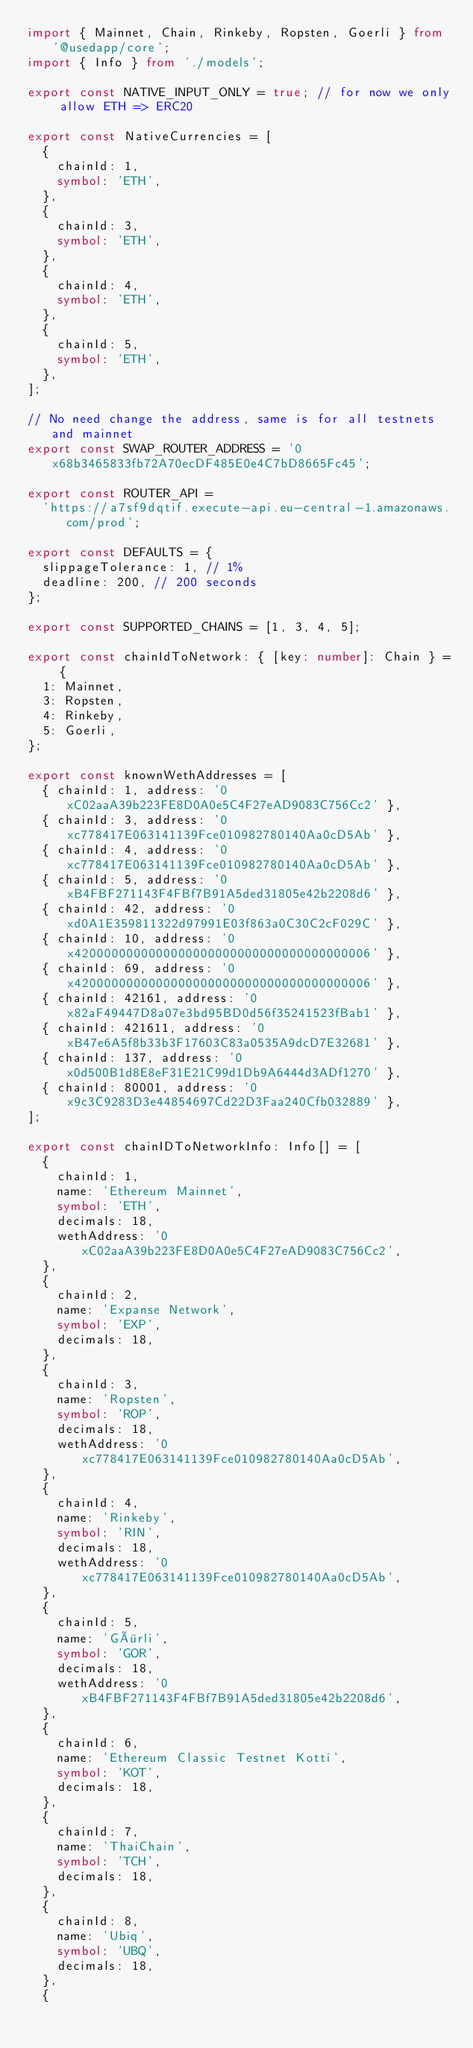<code> <loc_0><loc_0><loc_500><loc_500><_TypeScript_>import { Mainnet, Chain, Rinkeby, Ropsten, Goerli } from '@usedapp/core';
import { Info } from './models';

export const NATIVE_INPUT_ONLY = true; // for now we only allow ETH => ERC20

export const NativeCurrencies = [
  {
    chainId: 1,
    symbol: 'ETH',
  },
  {
    chainId: 3,
    symbol: 'ETH',
  },
  {
    chainId: 4,
    symbol: 'ETH',
  },
  {
    chainId: 5,
    symbol: 'ETH',
  },
];

// No need change the address, same is for all testnets and mainnet
export const SWAP_ROUTER_ADDRESS = '0x68b3465833fb72A70ecDF485E0e4C7bD8665Fc45';

export const ROUTER_API =
  'https://a7sf9dqtif.execute-api.eu-central-1.amazonaws.com/prod';

export const DEFAULTS = {
  slippageTolerance: 1, // 1%
  deadline: 200, // 200 seconds
};

export const SUPPORTED_CHAINS = [1, 3, 4, 5];

export const chainIdToNetwork: { [key: number]: Chain } = {
  1: Mainnet,
  3: Ropsten,
  4: Rinkeby,
  5: Goerli,
};

export const knownWethAddresses = [
  { chainId: 1, address: '0xC02aaA39b223FE8D0A0e5C4F27eAD9083C756Cc2' },
  { chainId: 3, address: '0xc778417E063141139Fce010982780140Aa0cD5Ab' },
  { chainId: 4, address: '0xc778417E063141139Fce010982780140Aa0cD5Ab' },
  { chainId: 5, address: '0xB4FBF271143F4FBf7B91A5ded31805e42b2208d6' },
  { chainId: 42, address: '0xd0A1E359811322d97991E03f863a0C30C2cF029C' },
  { chainId: 10, address: '0x4200000000000000000000000000000000000006' },
  { chainId: 69, address: '0x4200000000000000000000000000000000000006' },
  { chainId: 42161, address: '0x82aF49447D8a07e3bd95BD0d56f35241523fBab1' },
  { chainId: 421611, address: '0xB47e6A5f8b33b3F17603C83a0535A9dcD7E32681' },
  { chainId: 137, address: '0x0d500B1d8E8eF31E21C99d1Db9A6444d3ADf1270' },
  { chainId: 80001, address: '0x9c3C9283D3e44854697Cd22D3Faa240Cfb032889' },
];

export const chainIDToNetworkInfo: Info[] = [
  {
    chainId: 1,
    name: 'Ethereum Mainnet',
    symbol: 'ETH',
    decimals: 18,
    wethAddress: '0xC02aaA39b223FE8D0A0e5C4F27eAD9083C756Cc2',
  },
  {
    chainId: 2,
    name: 'Expanse Network',
    symbol: 'EXP',
    decimals: 18,
  },
  {
    chainId: 3,
    name: 'Ropsten',
    symbol: 'ROP',
    decimals: 18,
    wethAddress: '0xc778417E063141139Fce010982780140Aa0cD5Ab',
  },
  {
    chainId: 4,
    name: 'Rinkeby',
    symbol: 'RIN',
    decimals: 18,
    wethAddress: '0xc778417E063141139Fce010982780140Aa0cD5Ab',
  },
  {
    chainId: 5,
    name: 'Görli',
    symbol: 'GOR',
    decimals: 18,
    wethAddress: '0xB4FBF271143F4FBf7B91A5ded31805e42b2208d6',
  },
  {
    chainId: 6,
    name: 'Ethereum Classic Testnet Kotti',
    symbol: 'KOT',
    decimals: 18,
  },
  {
    chainId: 7,
    name: 'ThaiChain',
    symbol: 'TCH',
    decimals: 18,
  },
  {
    chainId: 8,
    name: 'Ubiq',
    symbol: 'UBQ',
    decimals: 18,
  },
  {</code> 